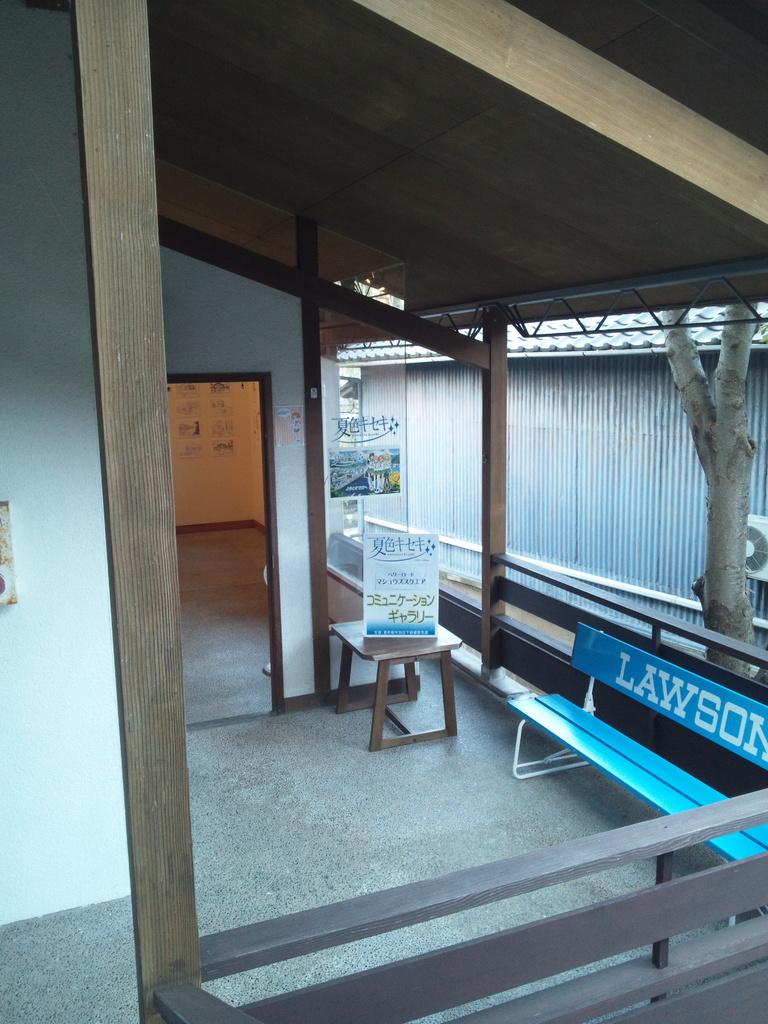What is written on the bench?
Provide a short and direct response. Lawson. What color is the word "lawson" in this picture?
Make the answer very short. White. 